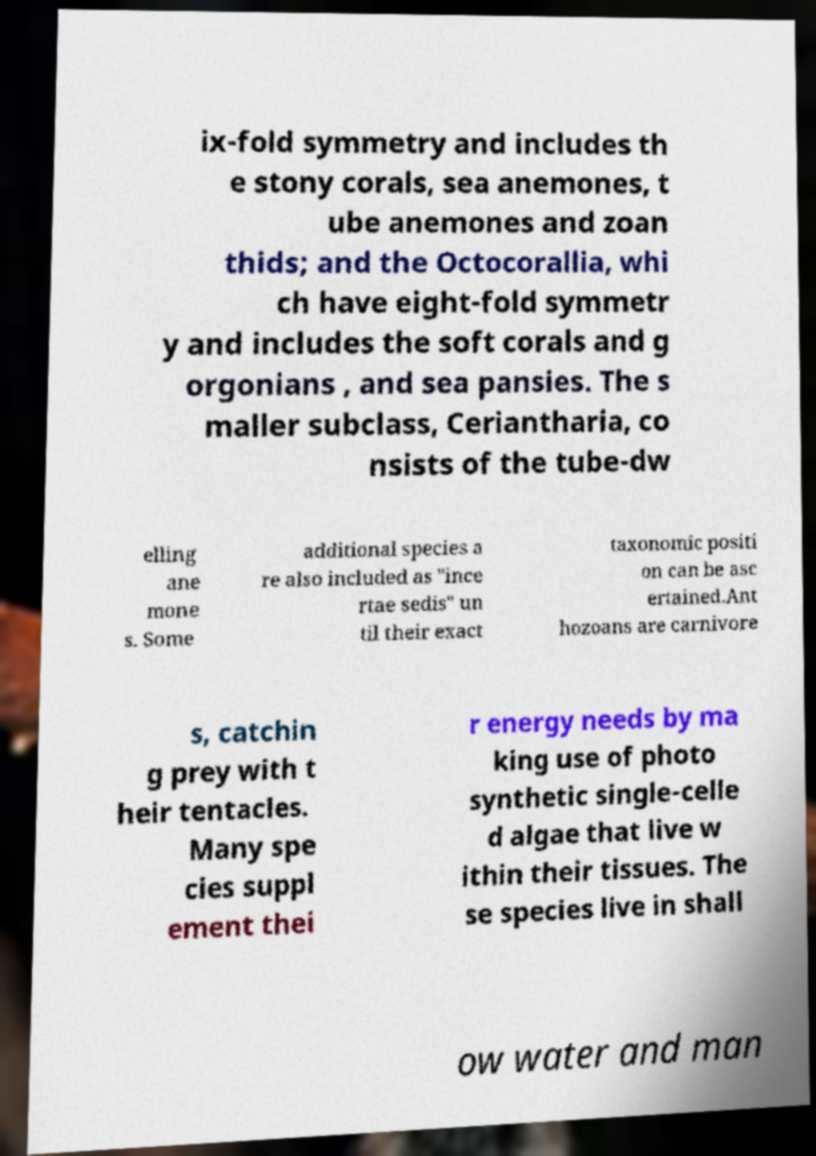Could you extract and type out the text from this image? ix-fold symmetry and includes th e stony corals, sea anemones, t ube anemones and zoan thids; and the Octocorallia, whi ch have eight-fold symmetr y and includes the soft corals and g orgonians , and sea pansies. The s maller subclass, Ceriantharia, co nsists of the tube-dw elling ane mone s. Some additional species a re also included as "ince rtae sedis" un til their exact taxonomic positi on can be asc ertained.Ant hozoans are carnivore s, catchin g prey with t heir tentacles. Many spe cies suppl ement thei r energy needs by ma king use of photo synthetic single-celle d algae that live w ithin their tissues. The se species live in shall ow water and man 